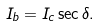Convert formula to latex. <formula><loc_0><loc_0><loc_500><loc_500>I _ { b } = I _ { c } \sec { \delta } .</formula> 